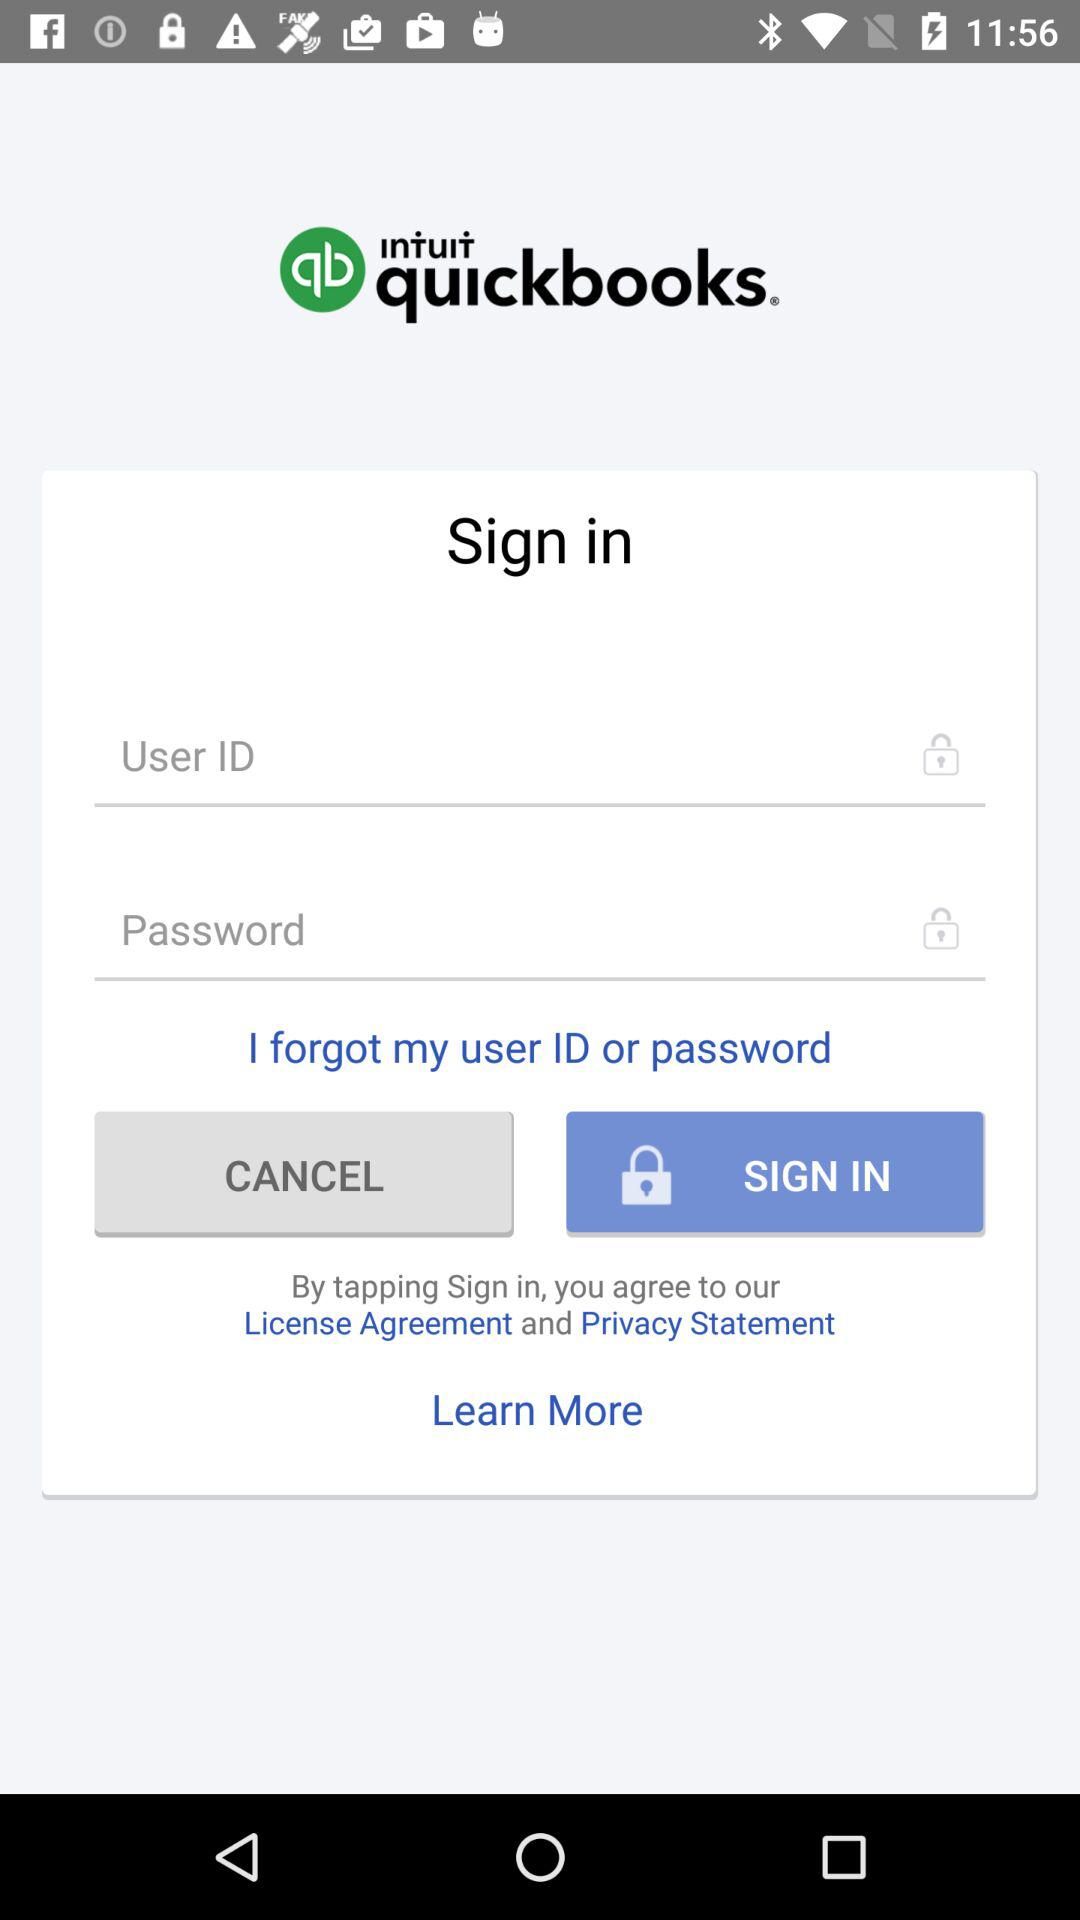What is the application name? The application name is "QuickBooks Online Accounting". 